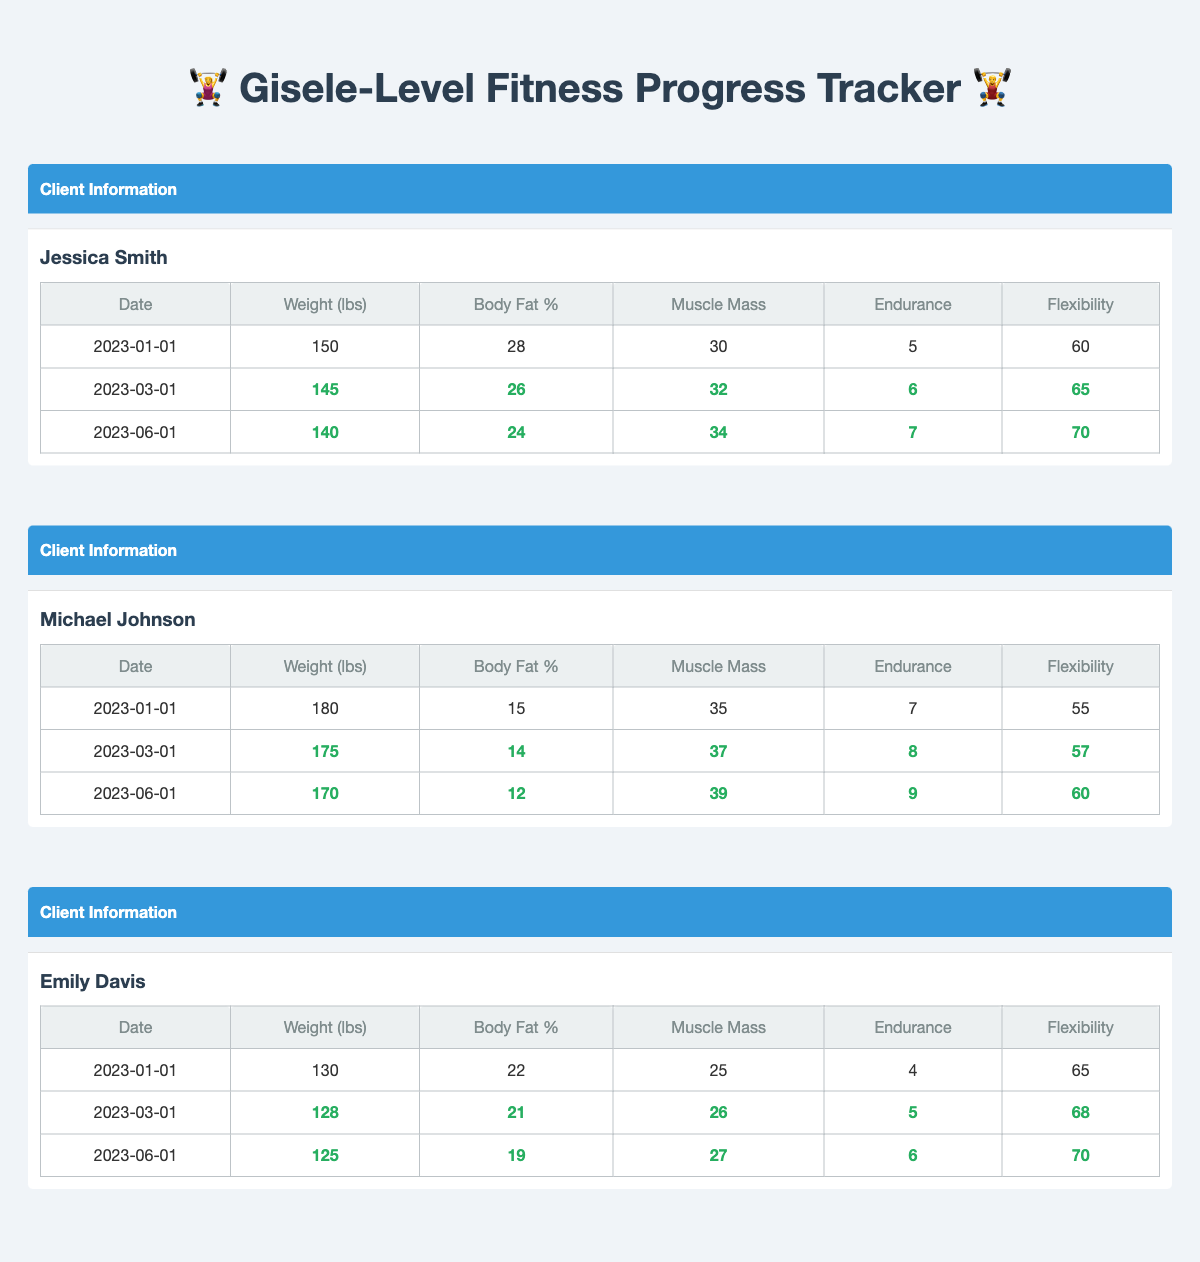What was Jessica Smith’s weight on 2023-06-01? From the table, under Jessica Smith's progress, we find the entry for 2023-06-01 which shows her weight as 140 lbs.
Answer: 140 lbs What is the total muscle mass gained by Michael Johnson from January to June 2023? Michael Johnson's muscle mass on January 1 was 35, and by June 1 it increased to 39. The total gain in muscle mass is 39 - 35 = 4 lbs.
Answer: 4 lbs Did Emily Davis improve her body fat percentage throughout the tracking period? To determine this, we can check her body fat percentage values: it starts at 22% and decreases to 19% by June 1. Since the percentage decreased, it indicates an improvement.
Answer: Yes What is the average endurance level for all clients on 2023-06-01? The endurance levels on June 1 are: Jessica (7), Michael (9), and Emily (6). Adding them gives 7 + 9 + 6 = 22. Since there are three clients, the average endurance is 22 / 3 = 7.33.
Answer: 7.33 What was the largest decrease in weight among the three clients over the tracked period? For each client, we calculate the weight decrease: Jessica went from 150 to 140 (decrease of 10 lbs), Michael from 180 to 170 (decrease of 10 lbs), and Emily from 130 to 125 (decrease of 5 lbs). The largest decrease is 10 lbs for both Jessica and Michael.
Answer: 10 lbs Did Michael Johnson’s flexibility increase over time? Checking the flexibility metric for Michael shows he started at 55 and increased to 60 by June 1. This means he experienced an improvement in flexibility.
Answer: Yes What is the change in body fat percentage for Jessica Smith from January to March 2023? Jessica's body fat percentage was 28% in January and decreased to 26% in March. The change can be calculated as 26 - 28 = -2%, indicating a reduction in body fat percentage.
Answer: -2% How many clients had a weight of 145 lbs or lower by June 2023? By checking each client's weight on June 1, we find: Jessica's weight is 140 lbs, Michael's is 170 lbs, and Emily's is 125 lbs. Therefore, only two clients (Jessica and Emily) weigh 145 lbs or lower.
Answer: 2 